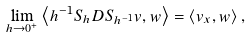<formula> <loc_0><loc_0><loc_500><loc_500>\lim _ { h \to 0 ^ { + } } \left < h ^ { - 1 } S _ { h } D S _ { h ^ { - 1 } } v , w \right > = \left < v _ { x } , w \right > ,</formula> 